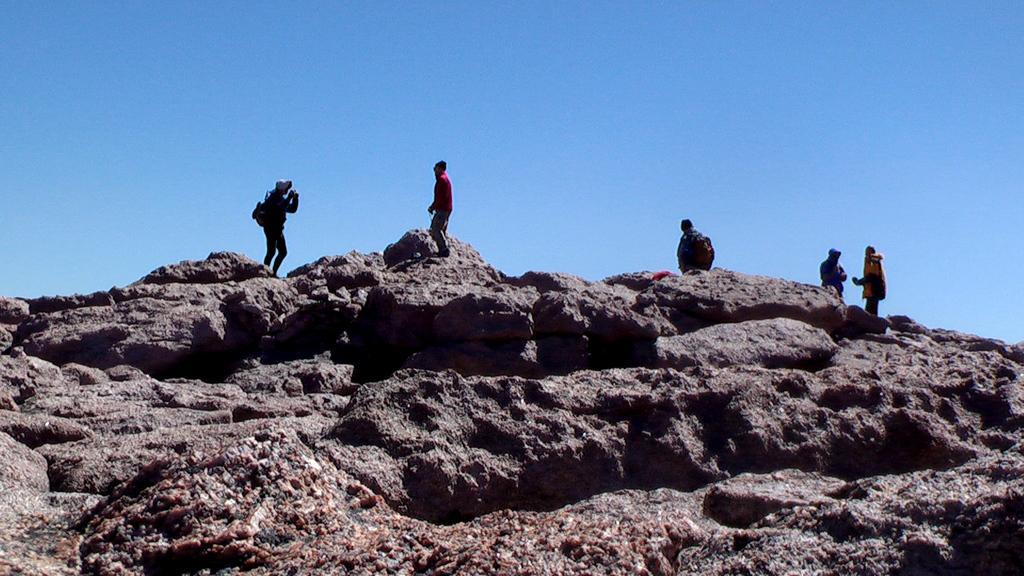Please provide a concise description of this image. In this image I can see few persons standing. In front the person is wearing red shirt and cream color pant and the person is standing on the rock, background the sky is in blue color. 